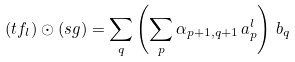Convert formula to latex. <formula><loc_0><loc_0><loc_500><loc_500>( t f _ { l } ) \odot ( s g ) = \sum _ { q } \left ( \sum _ { p } \alpha _ { p + 1 , q + 1 } \, a _ { p } ^ { l } \right ) \, b _ { q }</formula> 